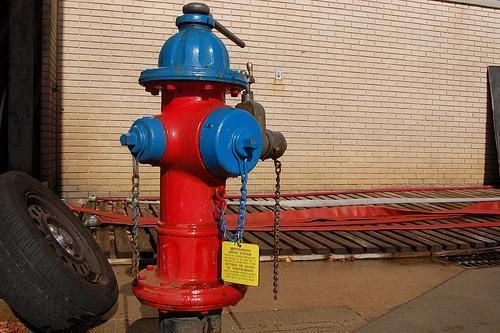How many fire hydrants are there?
Give a very brief answer. 1. 